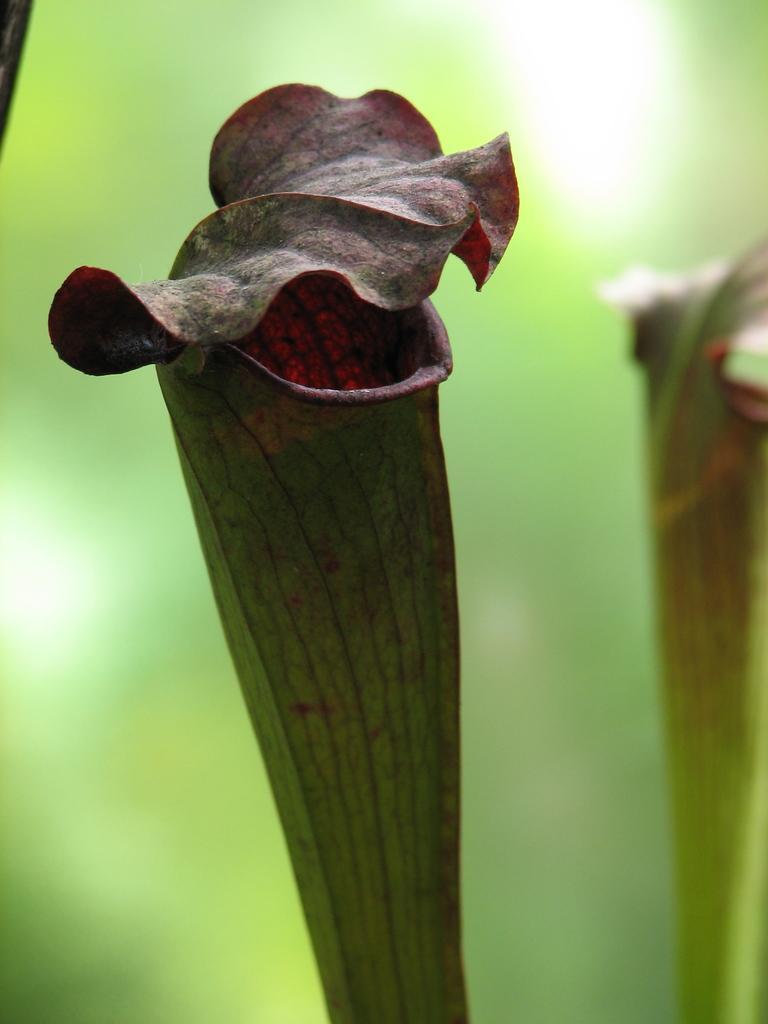How would you summarize this image in a sentence or two? Here we can see two flowers and in the background the image is blur. 